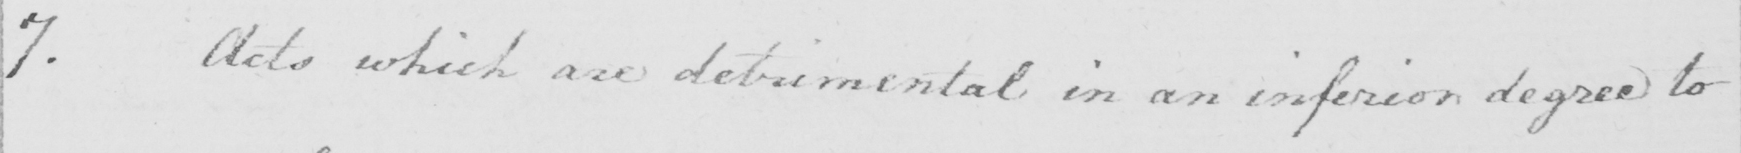Can you read and transcribe this handwriting? 7 . Acts which are detrimental in an inferior degree to 